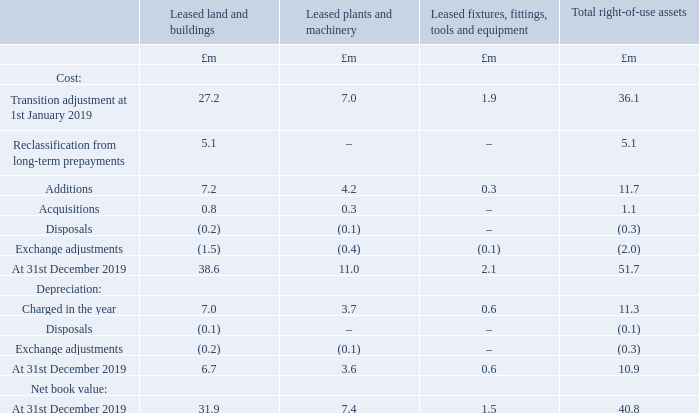14 Leases
Right-of-use assets
The vast majority of the right-of-use asset value relates to leased property where the Group leases a number of office and warehouse sites in a number of geographical locations. The remaining leases are largely made up of leased motor vehicles, where the Group makes use of leasing cars for sales and service engineers at a number of operating company locations. The average lease term is 4.3 years.
What is the vast majority of the right-of-use asset value related to? Leased property where the group leases a number of office and warehouse sites in a number of geographical locations. What is the average lease term? 4.3 years. What are the different types of leases making up the right-of-use assets in the table? Leased land and buildings, leased plants and machinery, leased fixtures, fittings, tools and equipment. Which type of lease had the largest amount of Acquisitions? 0.8>0.3>0
Answer: leased land and buildings. What was the total net book value of leased land and buildings and leased plant and machinery?
Answer scale should be: million. 31.9+7.4
Answer: 39.3. What was the sum of net book values of leased land and buildings and leased plant and machinery as a percentage of the net book value of the total right-of-use assets?
Answer scale should be: percent. (31.9+7.4)/40.8
Answer: 96.32. 